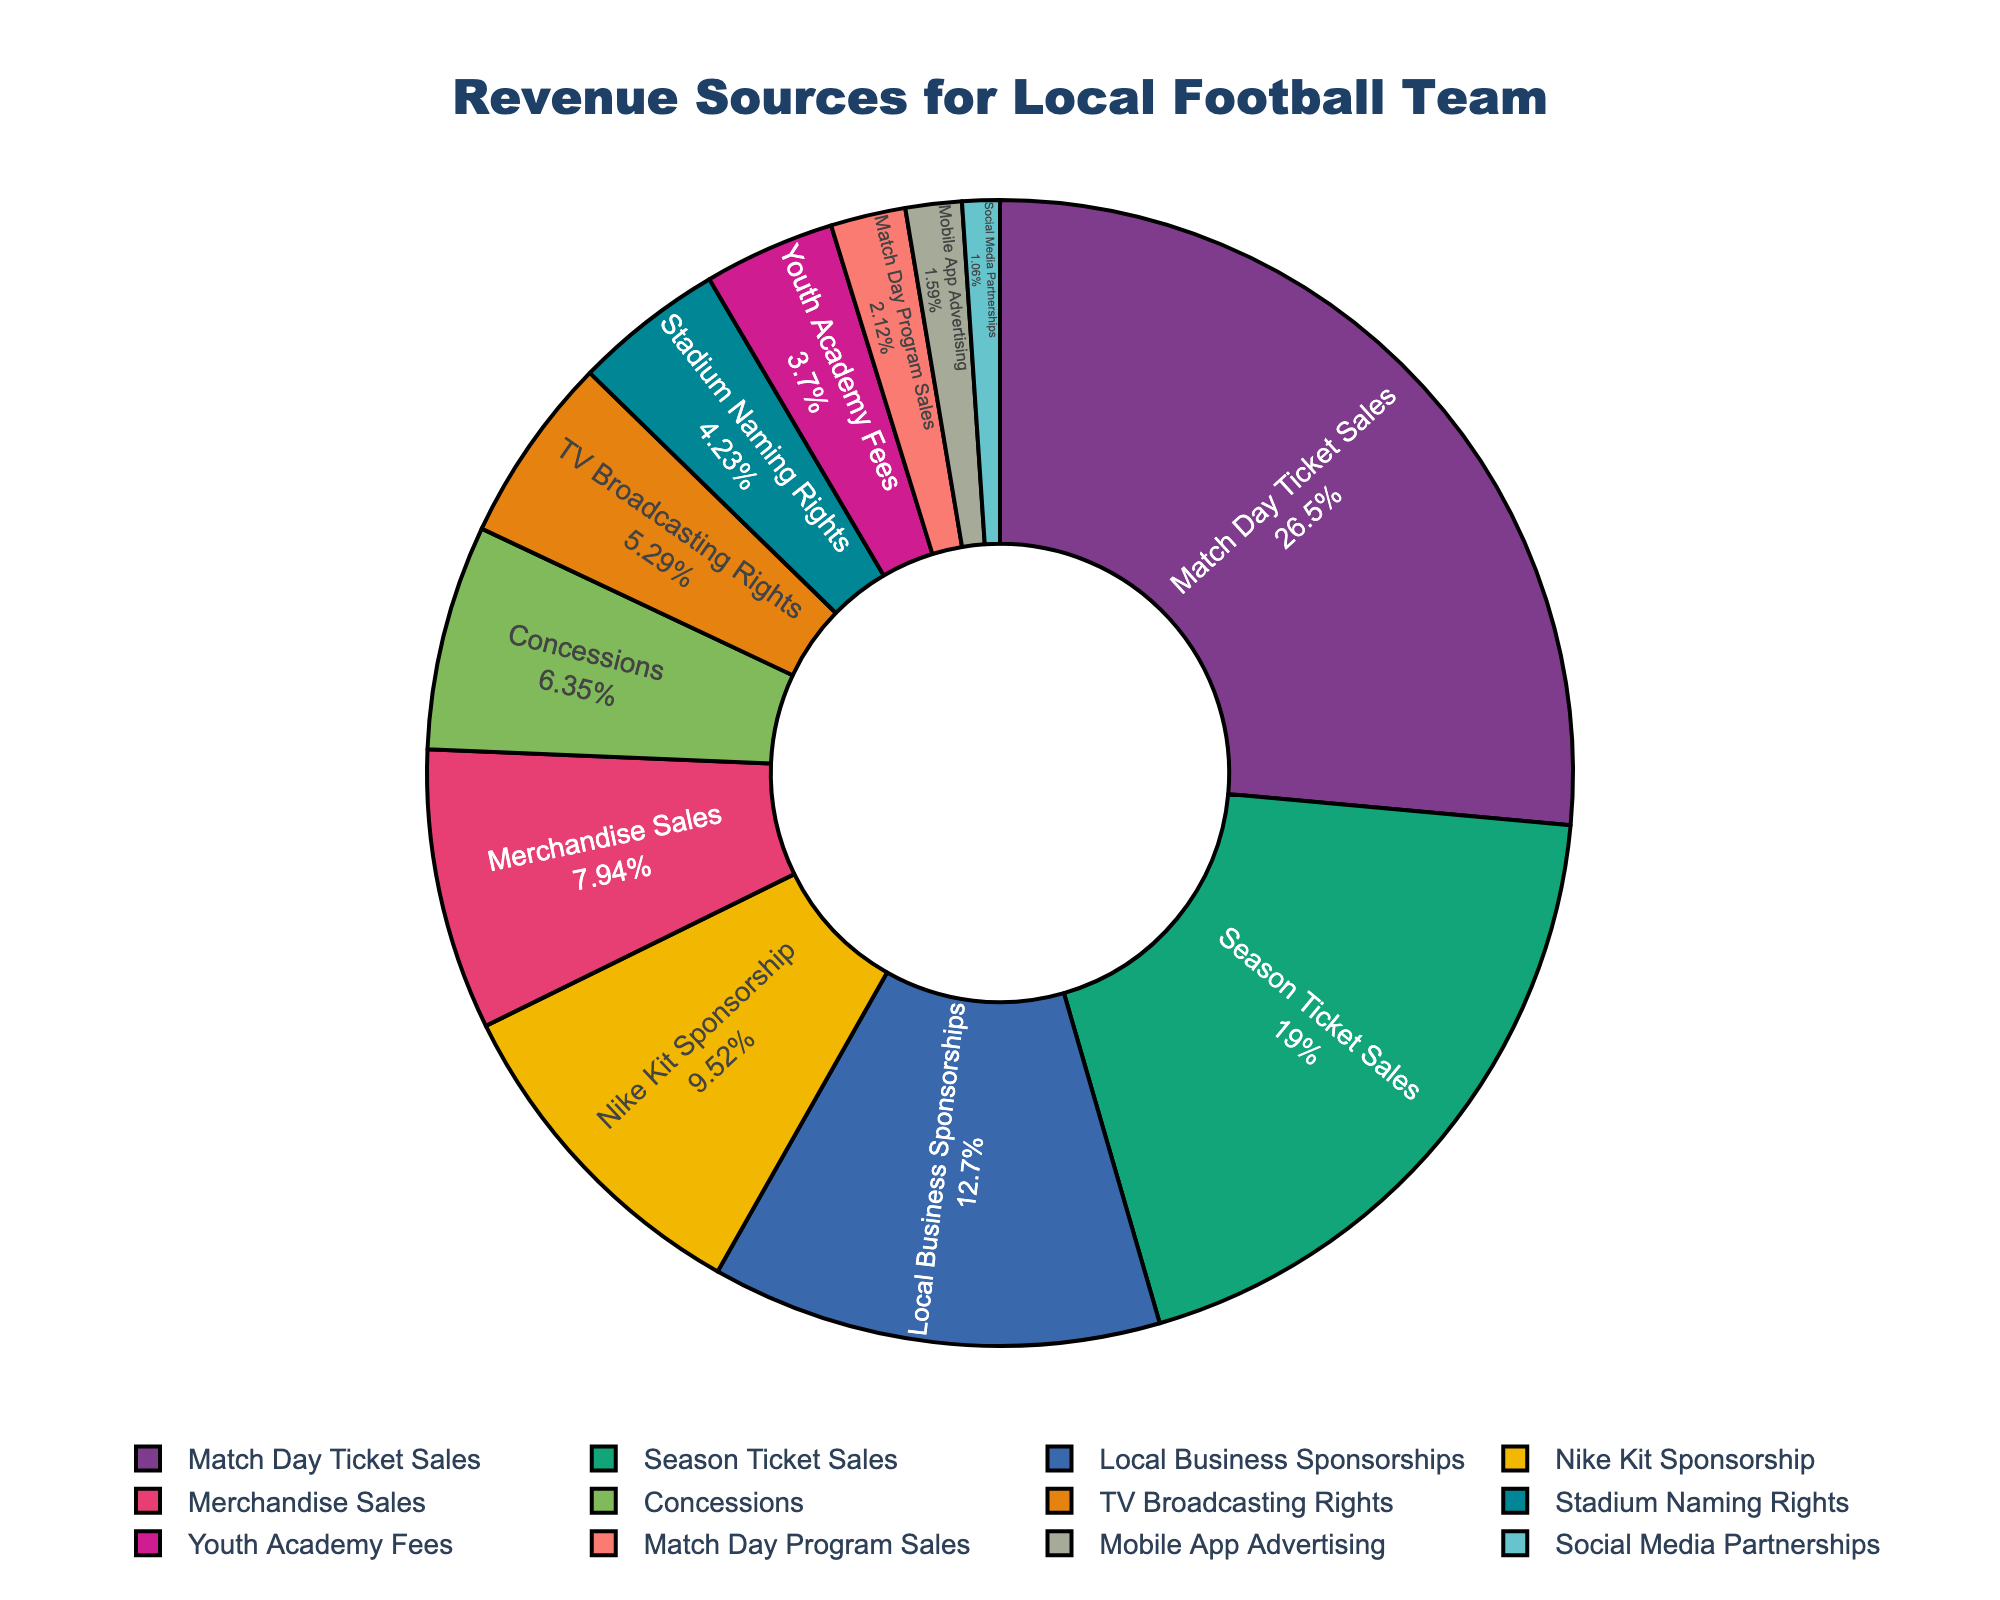What's the largest revenue source according to the pie chart? To determine the largest revenue source, look for the section of the pie chart with the highest percentage.
Answer: Match Day Ticket Sales Which revenue source contributes more, Merchandise Sales or Concessions? Compare the pie chart sections for Merchandise Sales and Concessions. Merchandise Sales contributes a larger portion than Concessions.
Answer: Merchandise Sales What's the combined revenue amount from Season Ticket Sales and Nike Kit Sponsorship? Sum the revenues from Season Ticket Sales and Nike Kit Sponsorship by referring to their respective sections in the pie chart. Season Ticket Sales is $1,800,000 and Nike Kit Sponsorship is $900,000. $1,800,000 + $900,000 = $2,700,000
Answer: $2,700,000 Is the revenue from Mobile App Advertising greater or less than the revenue from Social Media Partnerships? Check the sizes of the pie chart sections for Mobile App Advertising and Social Media Partnerships. Mobile App Advertising has a larger section than Social Media Partnerships.
Answer: Greater What percentage of the total revenue is generated by Local Business Sponsorships? Look at the percentage shown inside the section of the pie chart corresponding to Local Business Sponsorships.
Answer: Depends on the pie chart, typically around \( \frac{1,200,000}{total\ revenue} \times 100 \) percent Which has a smaller share, Youth Academy Fees or Stadium Naming Rights? Compare the pie chart sections for Youth Academy Fees and Stadium Naming Rights. Youth Academy Fees has a smaller section than Stadium Naming Rights.
Answer: Youth Academy Fees What is the percentage difference between Match Day Ticket Sales and TV Broadcasting Rights? Find the percentages for Match Day Ticket Sales and TV Broadcasting Rights in the pie chart. Subtract the smaller percentage (TV Broadcasting Rights) from the larger percentage (Match Day Ticket Sales).
Answer: Depends on the pie chart, typically \( percent_{Match Day} - percent_{TV} \) List the top three revenue sources in descending order. Identify the three largest sections in the pie chart and arrange them in descending order by their percentage of the total revenue.
Answer: Match Day Ticket Sales, Season Ticket Sales, Local Business Sponsorships What is the overall revenue share from all forms of advertising (Stadium Naming Rights, Mobile App Advertising, Social Media Partnerships)? Sum the percentages of the pie chart sections corresponding to Stadium Naming Rights, Mobile App Advertising, and Social Media Partnerships.
Answer: Depends on pie chart, typically around \( \frac{400,000+150,000+100,000}{total\ revenue} \times 100 \) Which color represents Merchandise Sales on the pie chart? Identify the section labeled Merchandise Sales and note its color.
Answer: Depends on the pie chart color scheme 